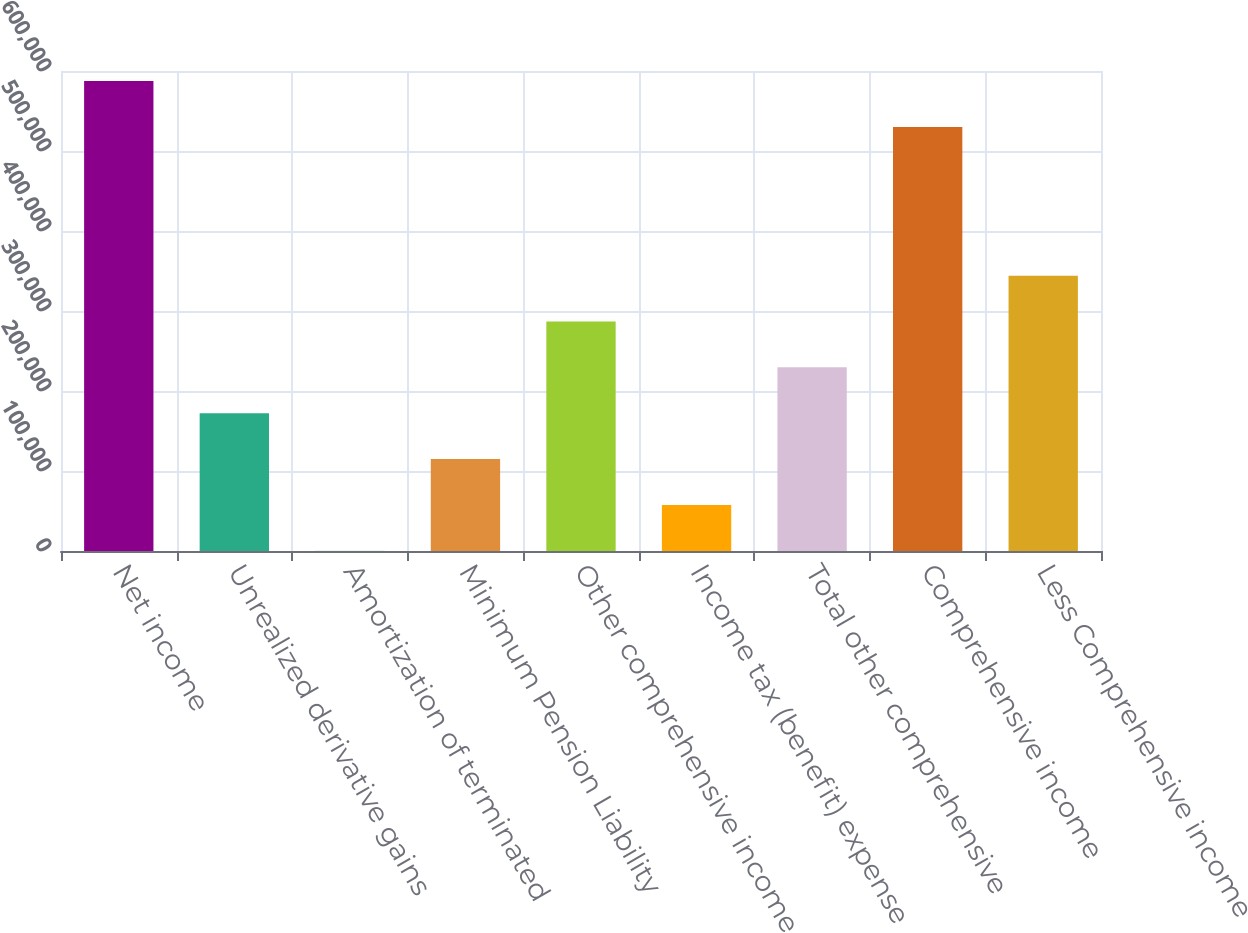<chart> <loc_0><loc_0><loc_500><loc_500><bar_chart><fcel>Net income<fcel>Unrealized derivative gains<fcel>Amortization of terminated<fcel>Minimum Pension Liability<fcel>Other comprehensive income<fcel>Income tax (benefit) expense<fcel>Total other comprehensive<fcel>Comprehensive income<fcel>Less Comprehensive income<nl><fcel>587380<fcel>172245<fcel>336<fcel>114942<fcel>286852<fcel>57639.1<fcel>229548<fcel>530077<fcel>344155<nl></chart> 